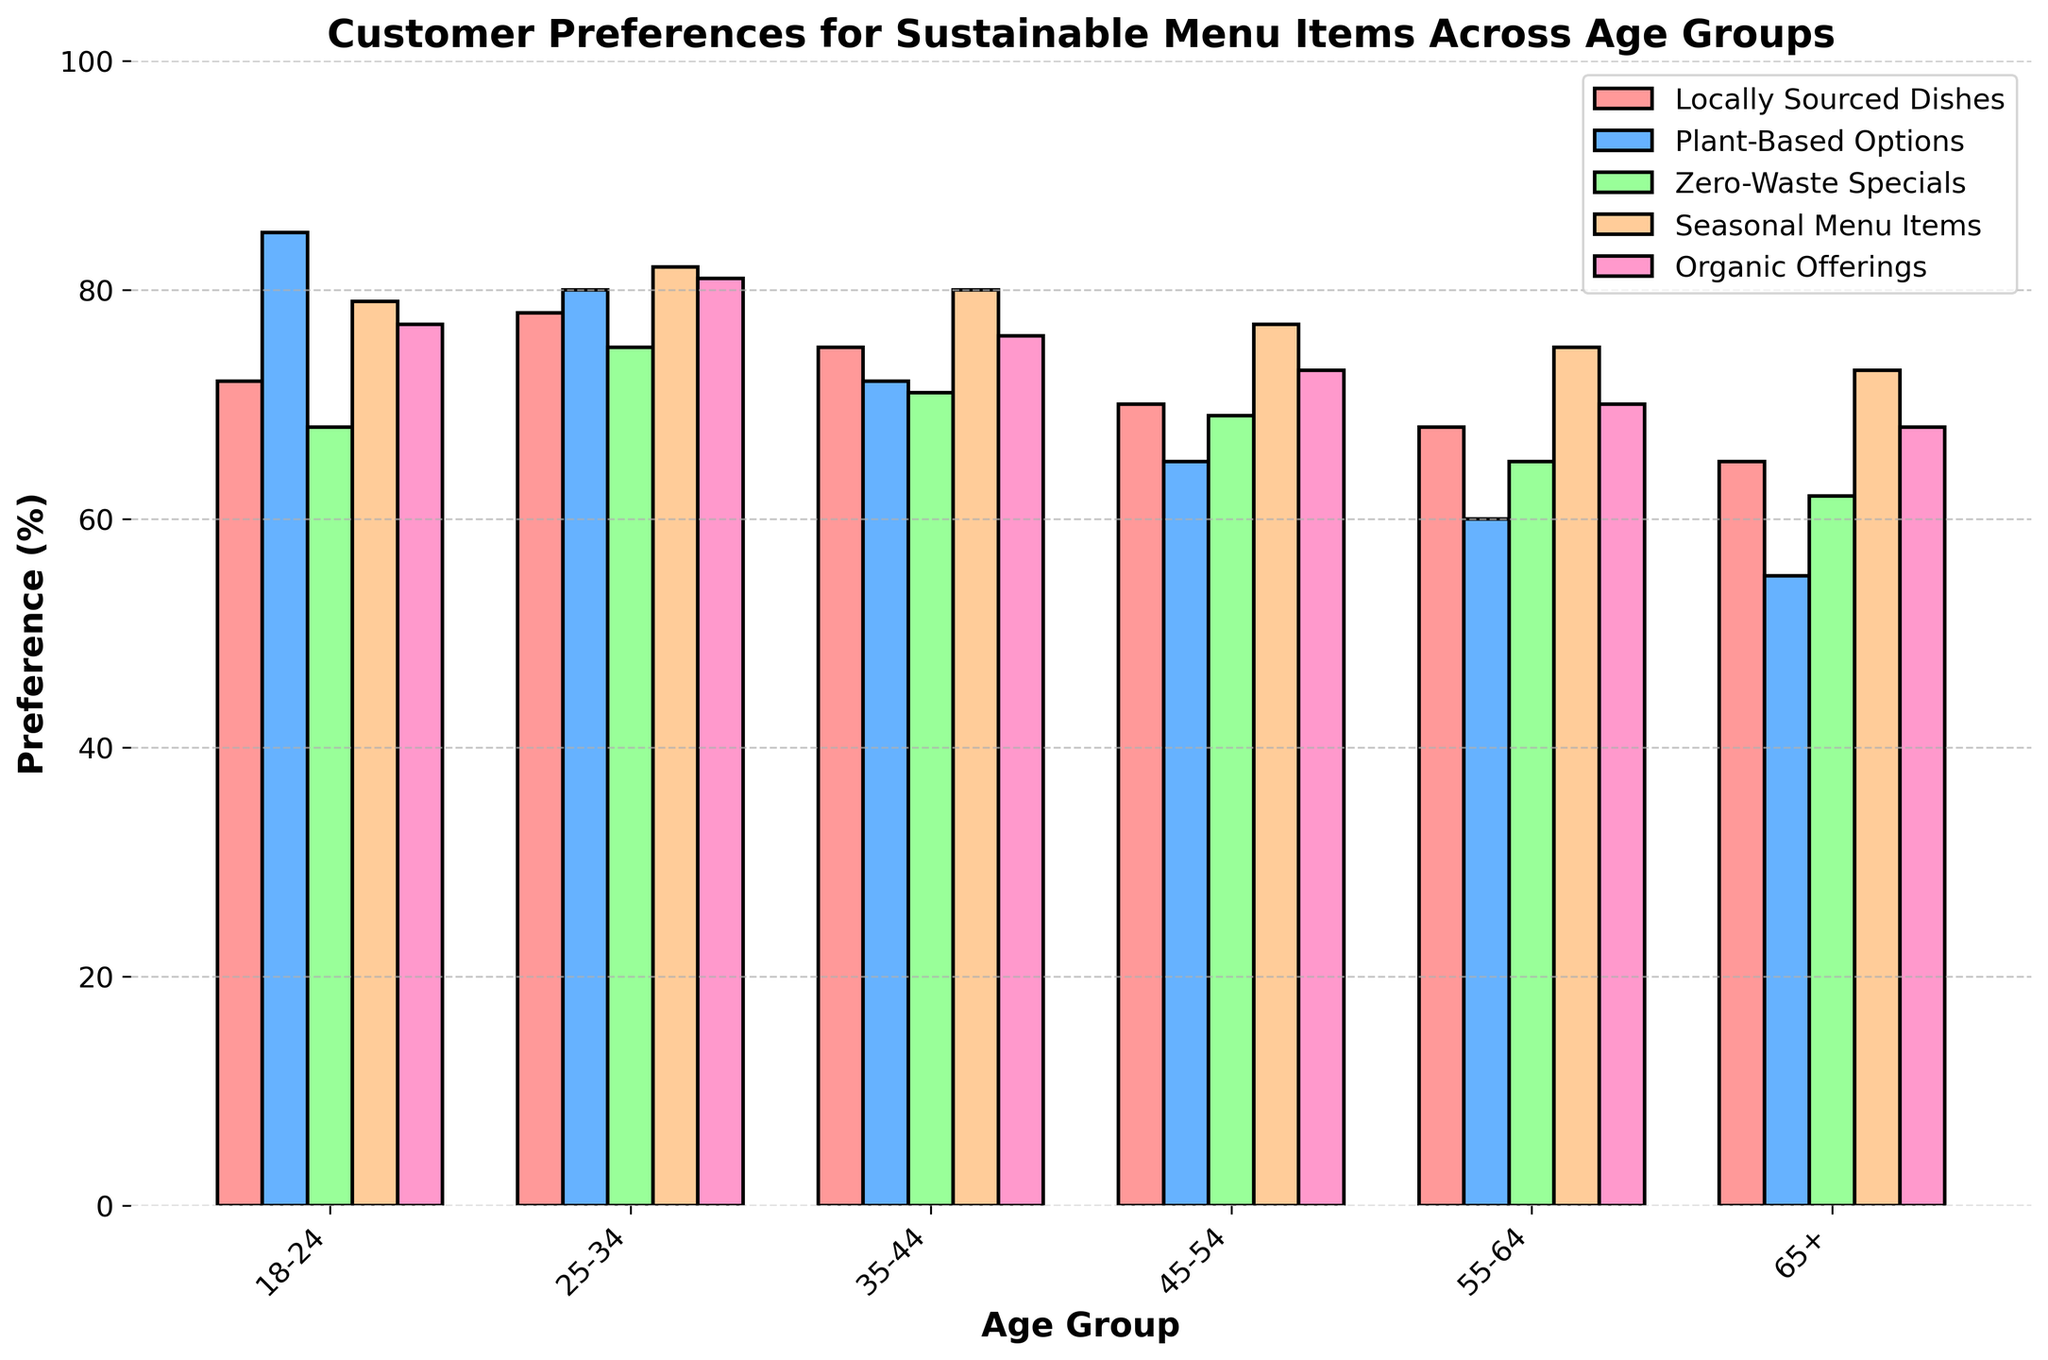Which age group shows the highest preference for Plant-Based Options? The bar for Plant-Based Options is tallest for the 18-24 age group, indicating the highest preference.
Answer: 18-24 Which age group has the lowest preference for Zero-Waste Specials? The bar for Zero-Waste Specials is shortest for the 65+ age group, indicating the lowest preference.
Answer: 65+ Which sustainable menu item is most preferred by the 25-34 age group? For the 25-34 age group, the bar for Locally Sourced Dishes, Plant-Based Options, Zero-Waste Specials, Seasonal Menu Items, and Organic Offerings should be compared. Plant-Based Options have the highest bar.
Answer: Plant-Based Options Compare the preferences for Seasonal Menu Items between the 35-44 and 55-64 age groups. Which age group prefers it more? The bar for Seasonal Menu Items is higher for the 35-44 age group compared to the 55-64 age group.
Answer: 35-44 What is the difference in preference for Organic Offerings between the 18-24 and 65+ age groups? The preference for Organic Offerings is 77% for the 18-24 age group and 68% for the 65+ age group. The difference is 77% - 68%.
Answer: 9% How does the preference for Locally Sourced Dishes change from the 18-24 age group to the 65+ age group? The preference for Locally Sourced Dishes starts at 72% for the 18-24 age group and declines gradually to 65% for the 65+ age group.
Answer: Decreases Which age group has a more even preference distribution across all sustainable menu items, 25-34 or 45-54? By comparing the heights of the bars across all categories for each age group, 25-34 has more uniform heights compared to the more varied heights for the 45-54 age group.
Answer: 25-34 Among the 55-64 age group, which two sustainable menu items have the most similar preference percentages? For the 55-64 age group, compare the height of the bars. Locally Sourced Dishes and Seasonal Menu Items have very similar heights, around 68% and 70% respectively.
Answer: Locally Sourced Dishes and Seasonal Menu Items 